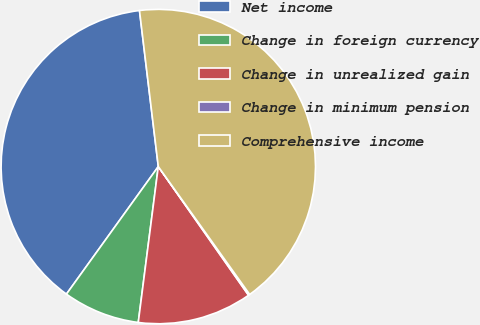<chart> <loc_0><loc_0><loc_500><loc_500><pie_chart><fcel>Net income<fcel>Change in foreign currency<fcel>Change in unrealized gain<fcel>Change in minimum pension<fcel>Comprehensive income<nl><fcel>38.16%<fcel>7.9%<fcel>11.77%<fcel>0.14%<fcel>42.04%<nl></chart> 